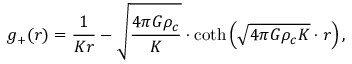<formula> <loc_0><loc_0><loc_500><loc_500>g _ { + } ( r ) = \frac { 1 } { K r } - \sqrt { \frac { 4 \pi G \rho _ { c } } { K } } \cdot \coth \left ( \sqrt { 4 \pi G \rho _ { c } K } \cdot r \right ) ,</formula> 